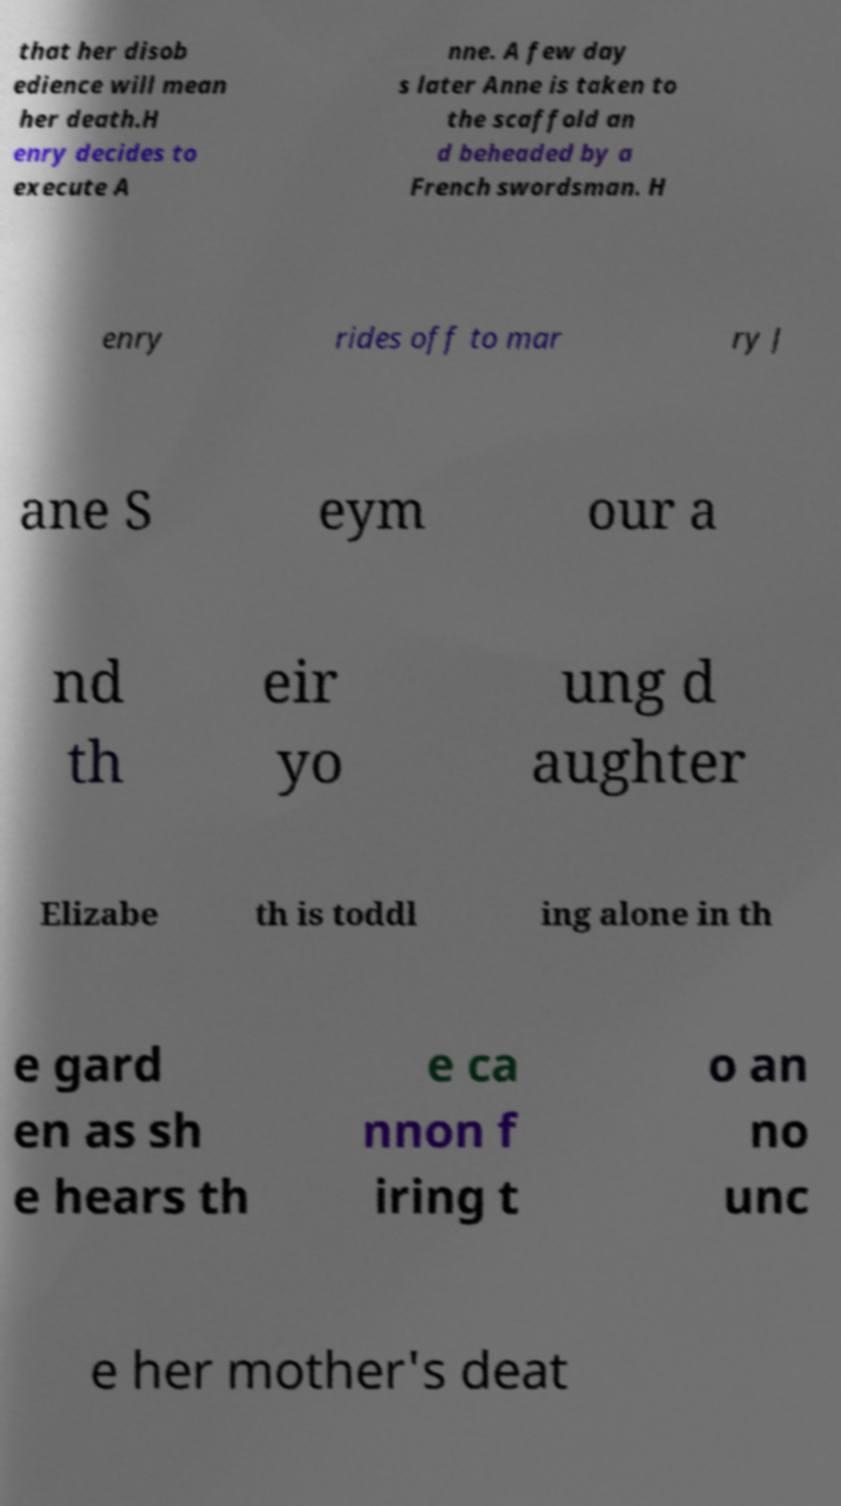There's text embedded in this image that I need extracted. Can you transcribe it verbatim? that her disob edience will mean her death.H enry decides to execute A nne. A few day s later Anne is taken to the scaffold an d beheaded by a French swordsman. H enry rides off to mar ry J ane S eym our a nd th eir yo ung d aughter Elizabe th is toddl ing alone in th e gard en as sh e hears th e ca nnon f iring t o an no unc e her mother's deat 